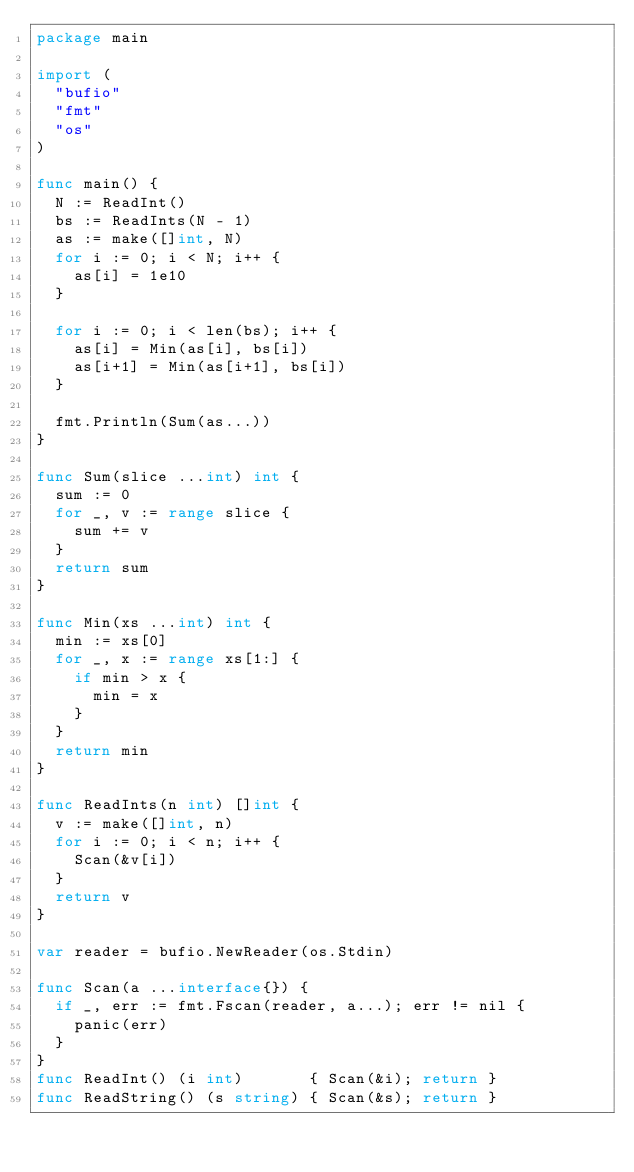<code> <loc_0><loc_0><loc_500><loc_500><_Go_>package main

import (
	"bufio"
	"fmt"
	"os"
)

func main() {
	N := ReadInt()
	bs := ReadInts(N - 1)
	as := make([]int, N)
	for i := 0; i < N; i++ {
		as[i] = 1e10
	}

	for i := 0; i < len(bs); i++ {
		as[i] = Min(as[i], bs[i])
		as[i+1] = Min(as[i+1], bs[i])
	}

	fmt.Println(Sum(as...))
}

func Sum(slice ...int) int {
	sum := 0
	for _, v := range slice {
		sum += v
	}
	return sum
}

func Min(xs ...int) int {
	min := xs[0]
	for _, x := range xs[1:] {
		if min > x {
			min = x
		}
	}
	return min
}

func ReadInts(n int) []int {
	v := make([]int, n)
	for i := 0; i < n; i++ {
		Scan(&v[i])
	}
	return v
}

var reader = bufio.NewReader(os.Stdin)

func Scan(a ...interface{}) {
	if _, err := fmt.Fscan(reader, a...); err != nil {
		panic(err)
	}
}
func ReadInt() (i int)       { Scan(&i); return }
func ReadString() (s string) { Scan(&s); return }
</code> 